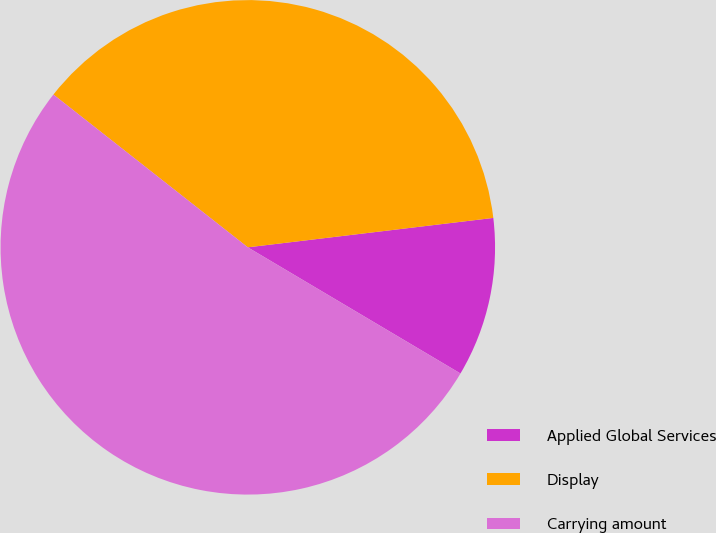<chart> <loc_0><loc_0><loc_500><loc_500><pie_chart><fcel>Applied Global Services<fcel>Display<fcel>Carrying amount<nl><fcel>10.42%<fcel>37.5%<fcel>52.08%<nl></chart> 